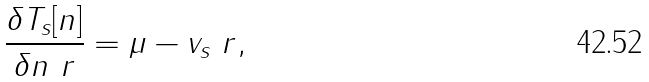Convert formula to latex. <formula><loc_0><loc_0><loc_500><loc_500>\frac { \delta T _ { s } [ n ] } { \delta n \ r } = \mu - v _ { s } \ r ,</formula> 